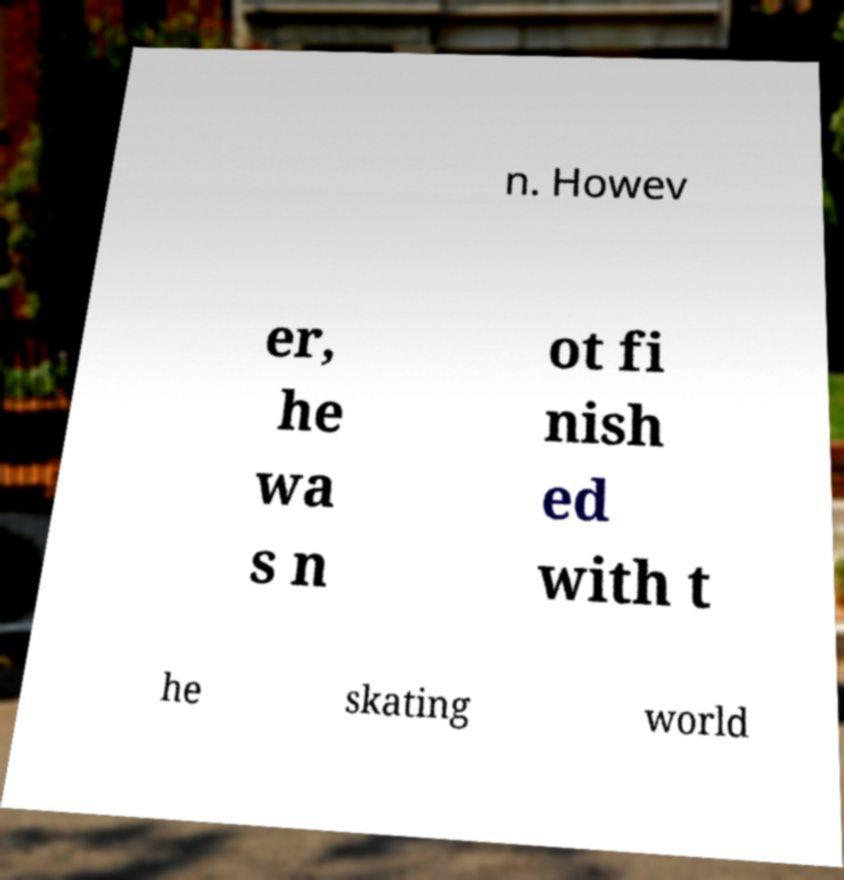Can you accurately transcribe the text from the provided image for me? n. Howev er, he wa s n ot fi nish ed with t he skating world 